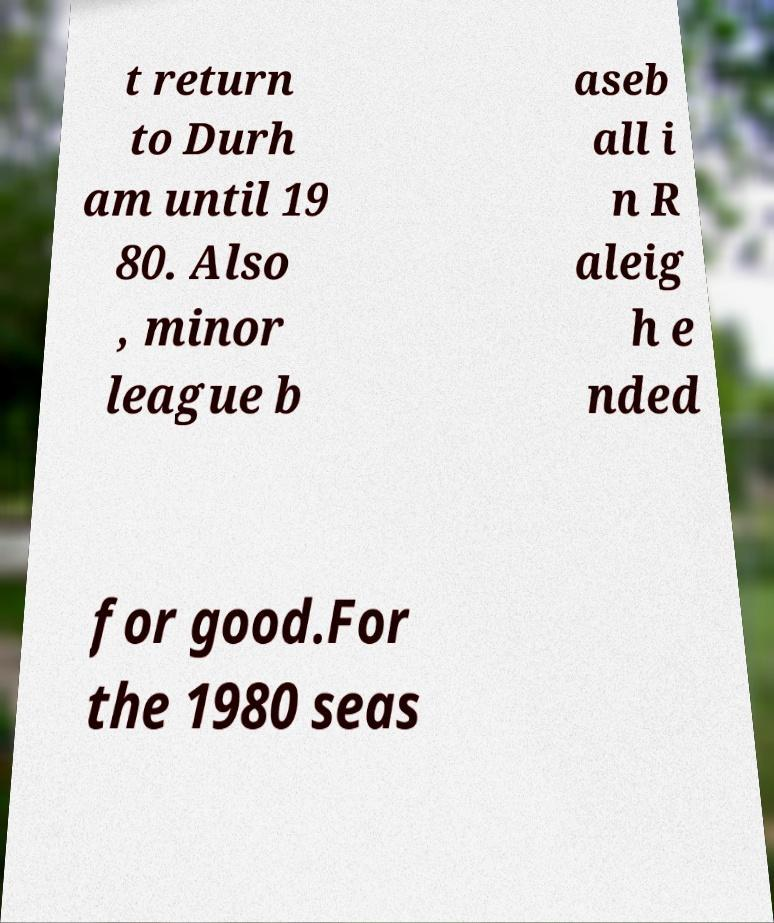Please read and relay the text visible in this image. What does it say? t return to Durh am until 19 80. Also , minor league b aseb all i n R aleig h e nded for good.For the 1980 seas 